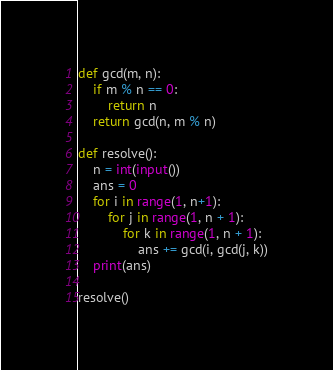Convert code to text. <code><loc_0><loc_0><loc_500><loc_500><_Python_>def gcd(m, n):
	if m % n == 0:
		return n
	return gcd(n, m % n)

def resolve():
	n = int(input())
	ans = 0
	for i in range(1, n+1):
		for j in range(1, n + 1):
			for k in range(1, n + 1):
				ans += gcd(i, gcd(j, k))
	print(ans)

resolve()</code> 